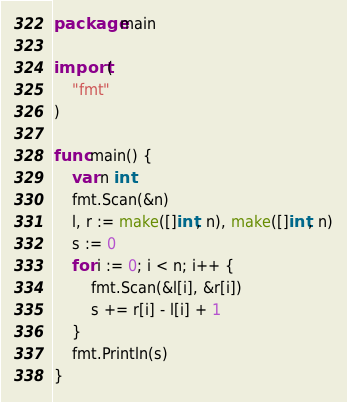<code> <loc_0><loc_0><loc_500><loc_500><_Go_>package main

import (
	"fmt"
)

func main() {
	var n int
	fmt.Scan(&n)
	l, r := make([]int, n), make([]int, n)
	s := 0
	for i := 0; i < n; i++ {
		fmt.Scan(&l[i], &r[i])
		s += r[i] - l[i] + 1
	}
	fmt.Println(s)
}
</code> 